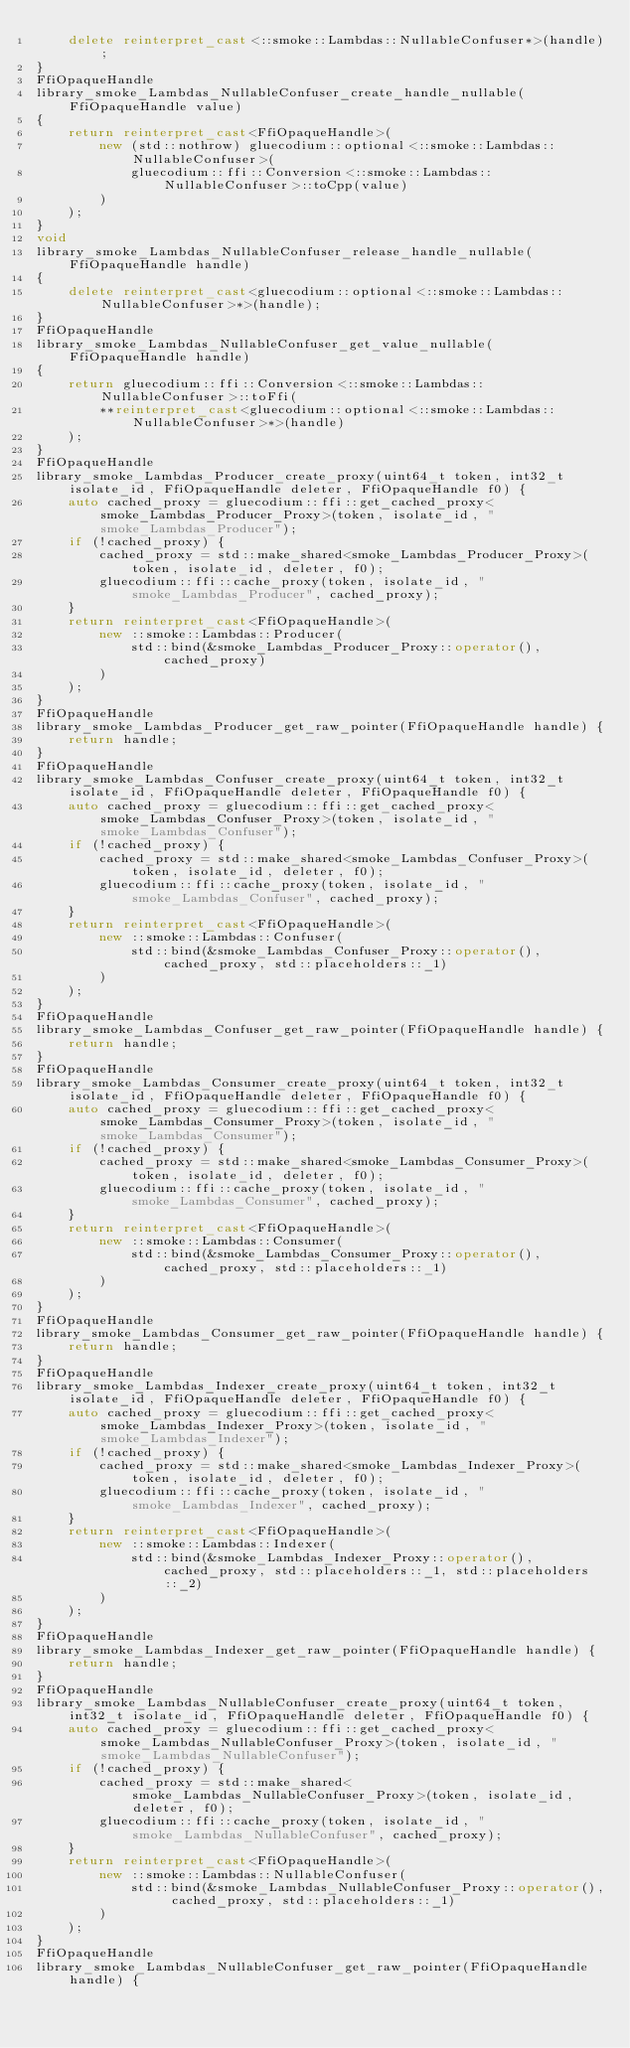<code> <loc_0><loc_0><loc_500><loc_500><_C++_>    delete reinterpret_cast<::smoke::Lambdas::NullableConfuser*>(handle);
}
FfiOpaqueHandle
library_smoke_Lambdas_NullableConfuser_create_handle_nullable(FfiOpaqueHandle value)
{
    return reinterpret_cast<FfiOpaqueHandle>(
        new (std::nothrow) gluecodium::optional<::smoke::Lambdas::NullableConfuser>(
            gluecodium::ffi::Conversion<::smoke::Lambdas::NullableConfuser>::toCpp(value)
        )
    );
}
void
library_smoke_Lambdas_NullableConfuser_release_handle_nullable(FfiOpaqueHandle handle)
{
    delete reinterpret_cast<gluecodium::optional<::smoke::Lambdas::NullableConfuser>*>(handle);
}
FfiOpaqueHandle
library_smoke_Lambdas_NullableConfuser_get_value_nullable(FfiOpaqueHandle handle)
{
    return gluecodium::ffi::Conversion<::smoke::Lambdas::NullableConfuser>::toFfi(
        **reinterpret_cast<gluecodium::optional<::smoke::Lambdas::NullableConfuser>*>(handle)
    );
}
FfiOpaqueHandle
library_smoke_Lambdas_Producer_create_proxy(uint64_t token, int32_t isolate_id, FfiOpaqueHandle deleter, FfiOpaqueHandle f0) {
    auto cached_proxy = gluecodium::ffi::get_cached_proxy<smoke_Lambdas_Producer_Proxy>(token, isolate_id, "smoke_Lambdas_Producer");
    if (!cached_proxy) {
        cached_proxy = std::make_shared<smoke_Lambdas_Producer_Proxy>(token, isolate_id, deleter, f0);
        gluecodium::ffi::cache_proxy(token, isolate_id, "smoke_Lambdas_Producer", cached_proxy);
    }
    return reinterpret_cast<FfiOpaqueHandle>(
        new ::smoke::Lambdas::Producer(
            std::bind(&smoke_Lambdas_Producer_Proxy::operator(), cached_proxy)
        )
    );
}
FfiOpaqueHandle
library_smoke_Lambdas_Producer_get_raw_pointer(FfiOpaqueHandle handle) {
    return handle;
}
FfiOpaqueHandle
library_smoke_Lambdas_Confuser_create_proxy(uint64_t token, int32_t isolate_id, FfiOpaqueHandle deleter, FfiOpaqueHandle f0) {
    auto cached_proxy = gluecodium::ffi::get_cached_proxy<smoke_Lambdas_Confuser_Proxy>(token, isolate_id, "smoke_Lambdas_Confuser");
    if (!cached_proxy) {
        cached_proxy = std::make_shared<smoke_Lambdas_Confuser_Proxy>(token, isolate_id, deleter, f0);
        gluecodium::ffi::cache_proxy(token, isolate_id, "smoke_Lambdas_Confuser", cached_proxy);
    }
    return reinterpret_cast<FfiOpaqueHandle>(
        new ::smoke::Lambdas::Confuser(
            std::bind(&smoke_Lambdas_Confuser_Proxy::operator(), cached_proxy, std::placeholders::_1)
        )
    );
}
FfiOpaqueHandle
library_smoke_Lambdas_Confuser_get_raw_pointer(FfiOpaqueHandle handle) {
    return handle;
}
FfiOpaqueHandle
library_smoke_Lambdas_Consumer_create_proxy(uint64_t token, int32_t isolate_id, FfiOpaqueHandle deleter, FfiOpaqueHandle f0) {
    auto cached_proxy = gluecodium::ffi::get_cached_proxy<smoke_Lambdas_Consumer_Proxy>(token, isolate_id, "smoke_Lambdas_Consumer");
    if (!cached_proxy) {
        cached_proxy = std::make_shared<smoke_Lambdas_Consumer_Proxy>(token, isolate_id, deleter, f0);
        gluecodium::ffi::cache_proxy(token, isolate_id, "smoke_Lambdas_Consumer", cached_proxy);
    }
    return reinterpret_cast<FfiOpaqueHandle>(
        new ::smoke::Lambdas::Consumer(
            std::bind(&smoke_Lambdas_Consumer_Proxy::operator(), cached_proxy, std::placeholders::_1)
        )
    );
}
FfiOpaqueHandle
library_smoke_Lambdas_Consumer_get_raw_pointer(FfiOpaqueHandle handle) {
    return handle;
}
FfiOpaqueHandle
library_smoke_Lambdas_Indexer_create_proxy(uint64_t token, int32_t isolate_id, FfiOpaqueHandle deleter, FfiOpaqueHandle f0) {
    auto cached_proxy = gluecodium::ffi::get_cached_proxy<smoke_Lambdas_Indexer_Proxy>(token, isolate_id, "smoke_Lambdas_Indexer");
    if (!cached_proxy) {
        cached_proxy = std::make_shared<smoke_Lambdas_Indexer_Proxy>(token, isolate_id, deleter, f0);
        gluecodium::ffi::cache_proxy(token, isolate_id, "smoke_Lambdas_Indexer", cached_proxy);
    }
    return reinterpret_cast<FfiOpaqueHandle>(
        new ::smoke::Lambdas::Indexer(
            std::bind(&smoke_Lambdas_Indexer_Proxy::operator(), cached_proxy, std::placeholders::_1, std::placeholders::_2)
        )
    );
}
FfiOpaqueHandle
library_smoke_Lambdas_Indexer_get_raw_pointer(FfiOpaqueHandle handle) {
    return handle;
}
FfiOpaqueHandle
library_smoke_Lambdas_NullableConfuser_create_proxy(uint64_t token, int32_t isolate_id, FfiOpaqueHandle deleter, FfiOpaqueHandle f0) {
    auto cached_proxy = gluecodium::ffi::get_cached_proxy<smoke_Lambdas_NullableConfuser_Proxy>(token, isolate_id, "smoke_Lambdas_NullableConfuser");
    if (!cached_proxy) {
        cached_proxy = std::make_shared<smoke_Lambdas_NullableConfuser_Proxy>(token, isolate_id, deleter, f0);
        gluecodium::ffi::cache_proxy(token, isolate_id, "smoke_Lambdas_NullableConfuser", cached_proxy);
    }
    return reinterpret_cast<FfiOpaqueHandle>(
        new ::smoke::Lambdas::NullableConfuser(
            std::bind(&smoke_Lambdas_NullableConfuser_Proxy::operator(), cached_proxy, std::placeholders::_1)
        )
    );
}
FfiOpaqueHandle
library_smoke_Lambdas_NullableConfuser_get_raw_pointer(FfiOpaqueHandle handle) {</code> 